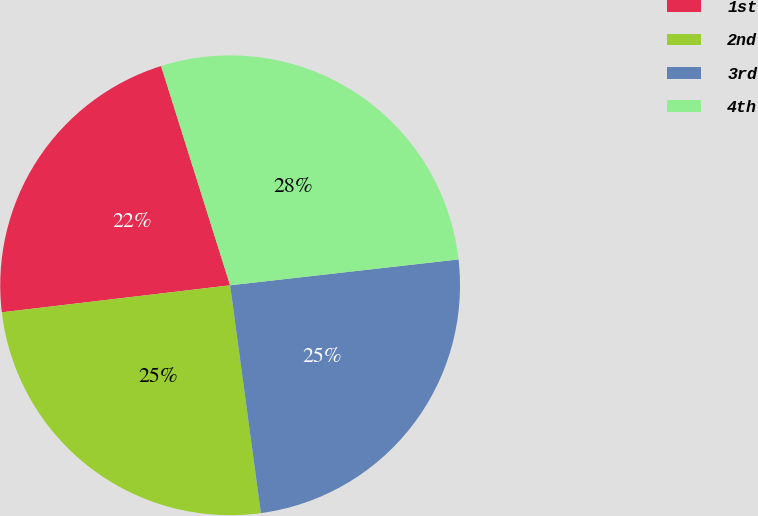Convert chart to OTSL. <chart><loc_0><loc_0><loc_500><loc_500><pie_chart><fcel>1st<fcel>2nd<fcel>3rd<fcel>4th<nl><fcel>22.02%<fcel>25.26%<fcel>24.66%<fcel>28.06%<nl></chart> 